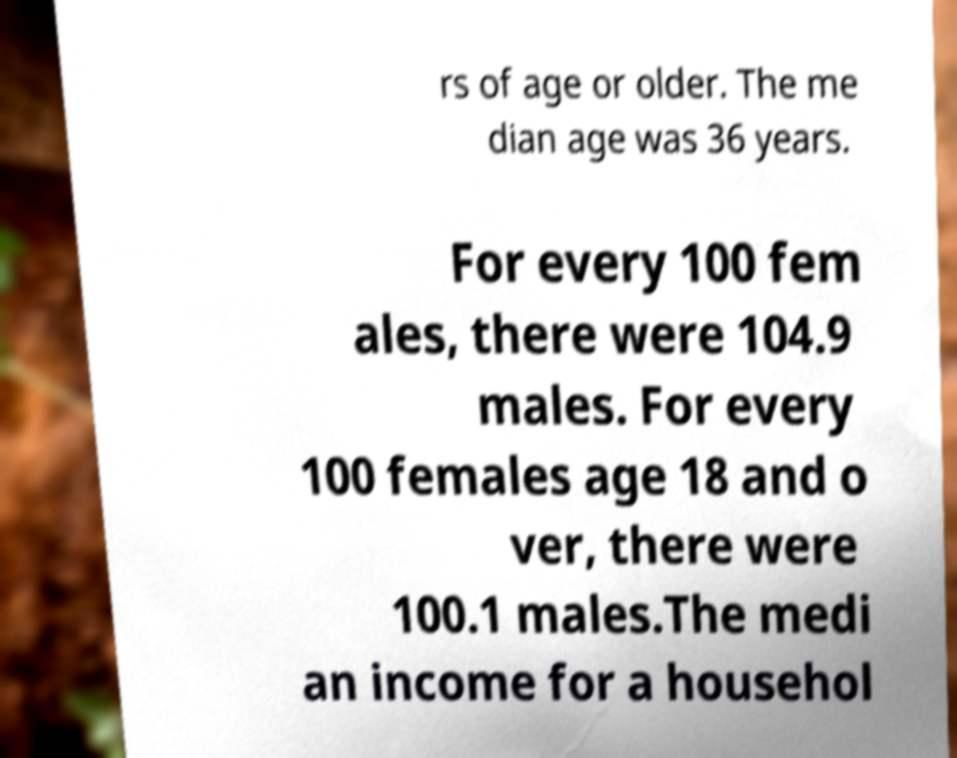For documentation purposes, I need the text within this image transcribed. Could you provide that? rs of age or older. The me dian age was 36 years. For every 100 fem ales, there were 104.9 males. For every 100 females age 18 and o ver, there were 100.1 males.The medi an income for a househol 